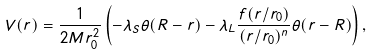Convert formula to latex. <formula><loc_0><loc_0><loc_500><loc_500>V ( r ) = \frac { 1 } { 2 M r _ { 0 } ^ { 2 } } \left ( - \lambda _ { S } \theta ( R - r ) - \lambda _ { L } \frac { f ( r / r _ { 0 } ) } { ( r / r _ { 0 } ) ^ { n } } \theta ( r - R ) \right ) ,</formula> 